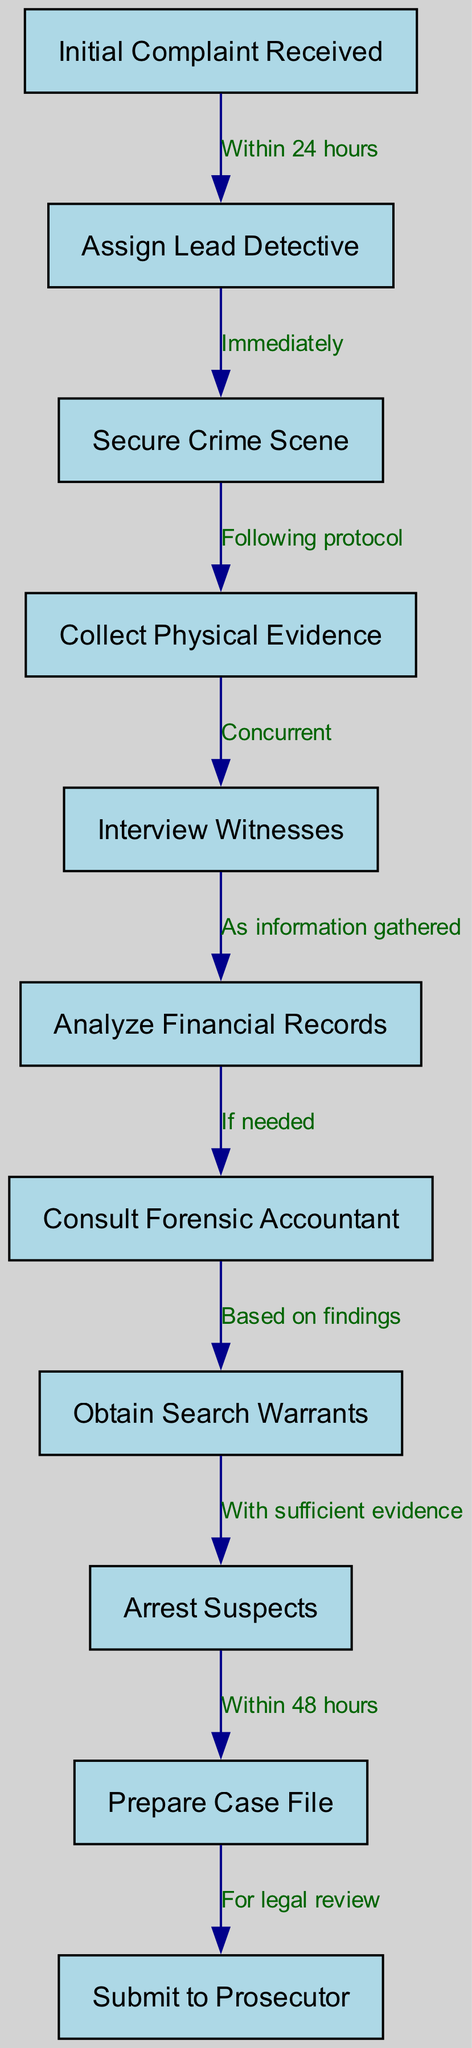What is the first step in the investigation process? The diagram shows that the first step in the investigation process is "Initial Complaint Received."
Answer: Initial Complaint Received How many nodes are there in the diagram? By counting the nodes listed in the data, we find there are a total of 11 distinct steps or actions in the investigation process.
Answer: 11 What is the time frame for assigning a lead detective? The diagram indicates that the lead detective should be assigned "Within 24 hours" of receiving the initial complaint.
Answer: Within 24 hours Which steps occur concurrently? The diagram specifies that "Collect Physical Evidence" and "Interview Witnesses" happen concurrently after securing the crime scene.
Answer: Collect Physical Evidence and Interview Witnesses What is needed to obtain search warrants? According to the diagram, obtaining search warrants is based on findings from the consultation with the forensic accountant, indicating that sufficient evidence or leads must be established first.
Answer: Based on findings What step follows after securing the crime scene? From the diagram flow, after securing the crime scene, the immediate next step is "Collect Physical Evidence."
Answer: Collect Physical Evidence What happens after arresting suspects? The diagram indicates that the next step after "Arrest Suspects" is "Prepare Case File," meaning documentation and organization of the case must occur immediately following arrests.
Answer: Prepare Case File What action is taken if needed after analyzing financial records? The diagram specifies that if the analysis of financial records suggests it, a consultation with a forensic accountant will be initiated as the next step.
Answer: Consult Forensic Accountant How soon after arresting suspects should the case file be prepared? The diagram states that the case file should be prepared "Within 48 hours" after the arrests are made, indicating a time-sensitive requirement for documentation.
Answer: Within 48 hours 